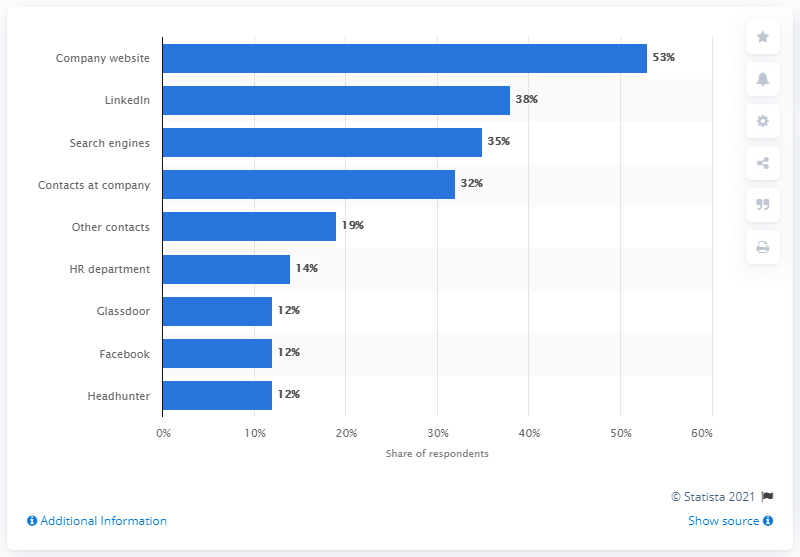Give some essential details in this illustration. A survey reveals that 38% of job switchers used LinkedIn as their primary source of information before applying for a job. 